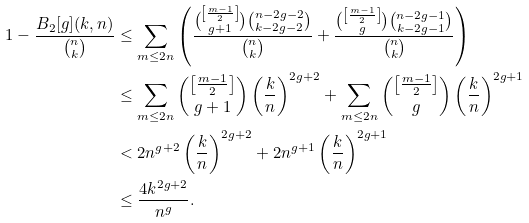<formula> <loc_0><loc_0><loc_500><loc_500>1 - \frac { B _ { 2 } [ g ] ( k , n ) } { \binom { n } { k } } & \leq \sum _ { m \leq 2 n } \left ( \frac { \binom { \left [ \frac { m - 1 } { 2 } \right ] } { g + 1 } \binom { n - 2 g - 2 } { k - 2 g - 2 } } { \binom { n } { k } } + \frac { \binom { \left [ \frac { m - 1 } { 2 } \right ] } { g } \binom { n - 2 g - 1 } { k - 2 g - 1 } } { \binom { n } { k } } \right ) \\ & \leq \sum _ { m \leq 2 n } \binom { \left [ \frac { m - 1 } { 2 } \right ] } { g + 1 } \left ( \frac { k } { n } \right ) ^ { 2 g + 2 } + \sum _ { m \leq 2 n } \binom { \left [ \frac { m - 1 } { 2 } \right ] } { g } \left ( \frac { k } { n } \right ) ^ { 2 g + 1 } \\ & < 2 n ^ { g + 2 } \left ( \frac { k } { n } \right ) ^ { 2 g + 2 } + 2 n ^ { g + 1 } \left ( \frac { k } { n } \right ) ^ { 2 g + 1 } \\ & \leq \frac { 4 k ^ { 2 g + 2 } } { n ^ { g } } .</formula> 